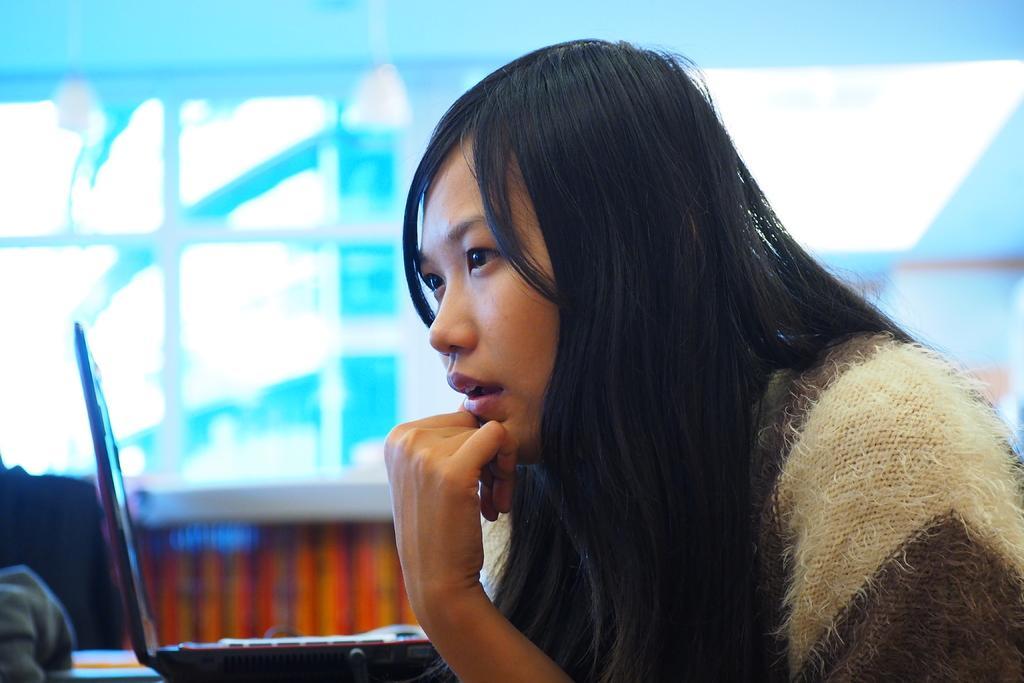How would you summarize this image in a sentence or two? On the left side of the image we can see a table and there is a laptop placed on the table. In the center there is a lady sitting. In the background there is a wall. 